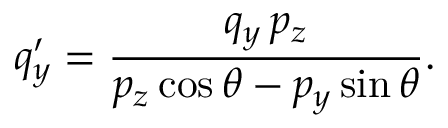Convert formula to latex. <formula><loc_0><loc_0><loc_500><loc_500>q _ { y } ^ { \prime } = \frac { q _ { y } \, p _ { z } } { p _ { z } \cos \theta - p _ { y } \sin \theta } .</formula> 